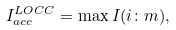Convert formula to latex. <formula><loc_0><loc_0><loc_500><loc_500>I _ { a c c } ^ { L O C C } = \max I ( i \colon m ) ,</formula> 